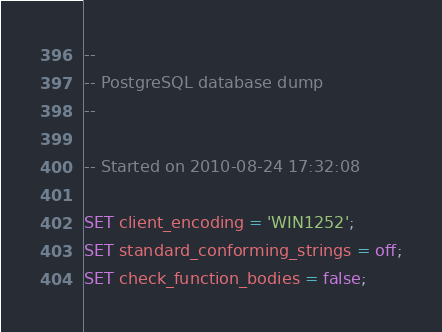<code> <loc_0><loc_0><loc_500><loc_500><_SQL_>--
-- PostgreSQL database dump
--

-- Started on 2010-08-24 17:32:08

SET client_encoding = 'WIN1252';
SET standard_conforming_strings = off;
SET check_function_bodies = false;</code> 